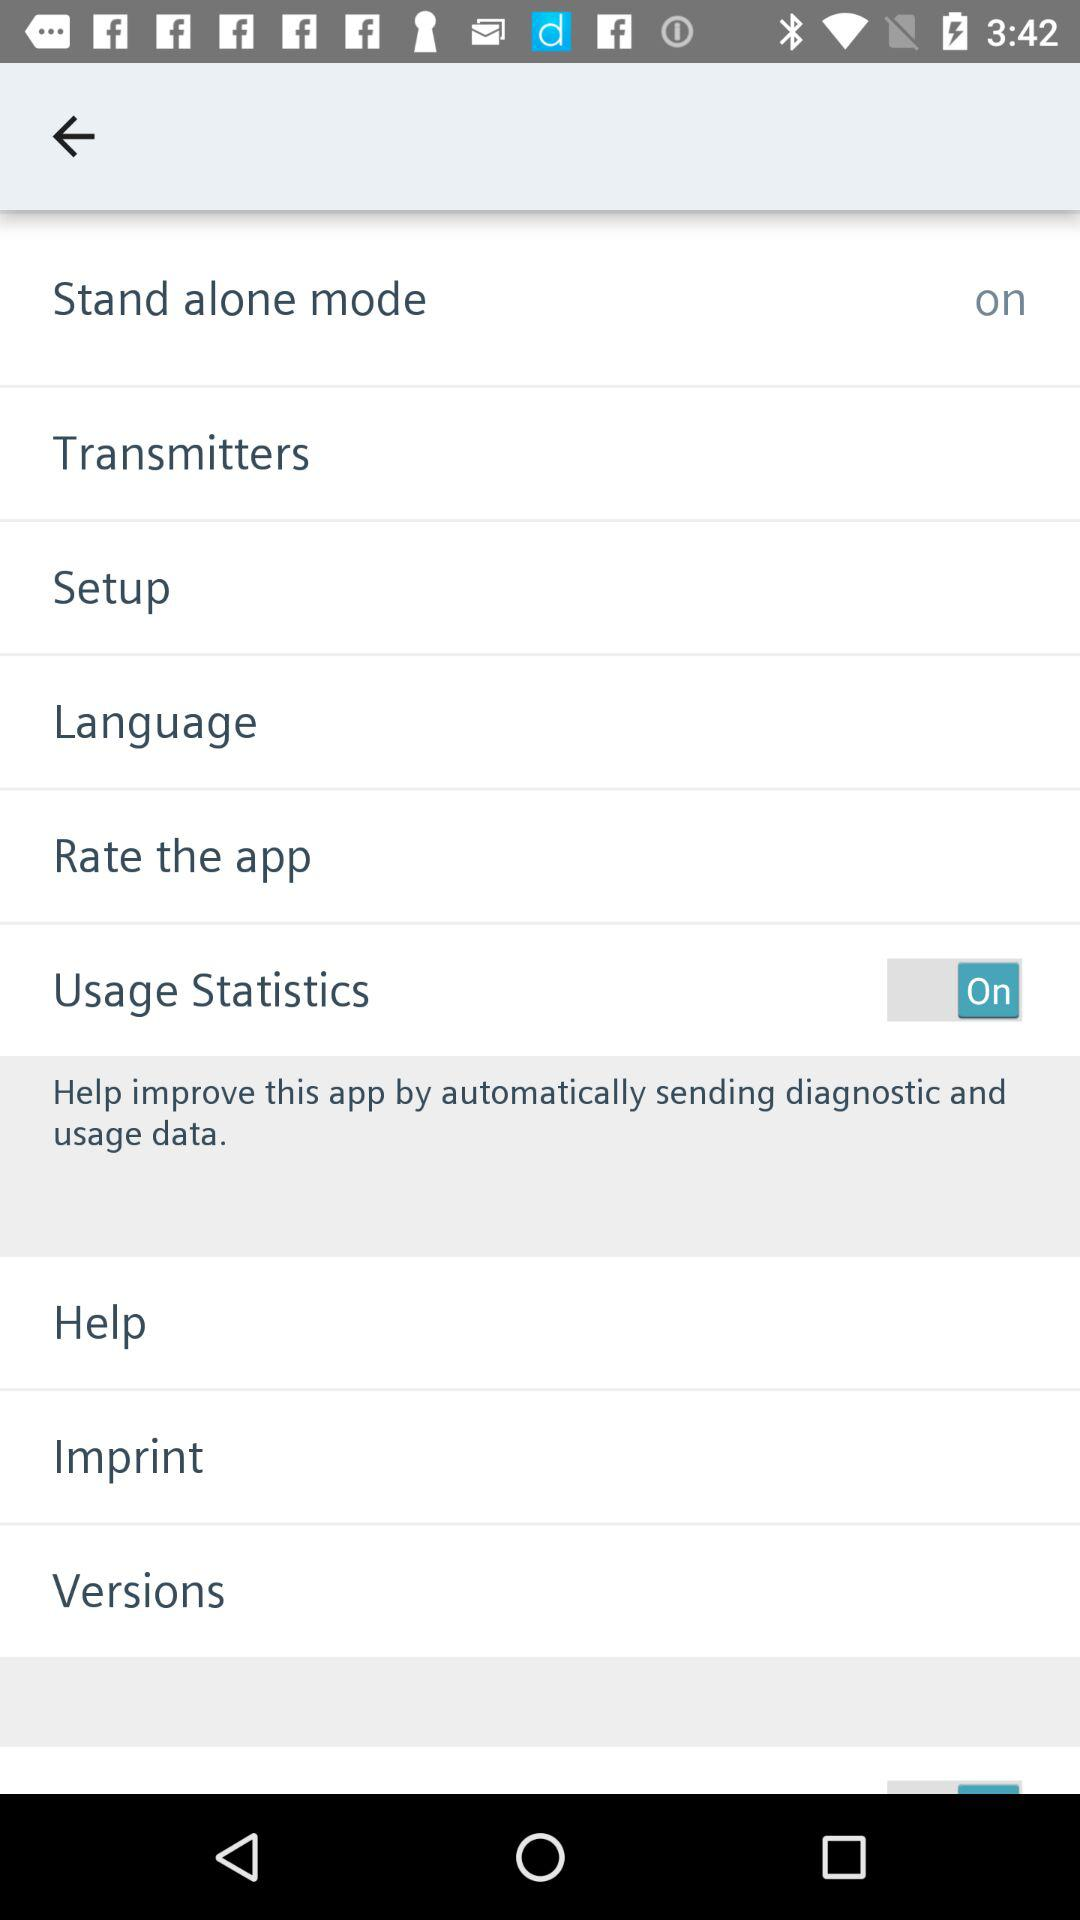How many items have the text 'on'?
Answer the question using a single word or phrase. 1 